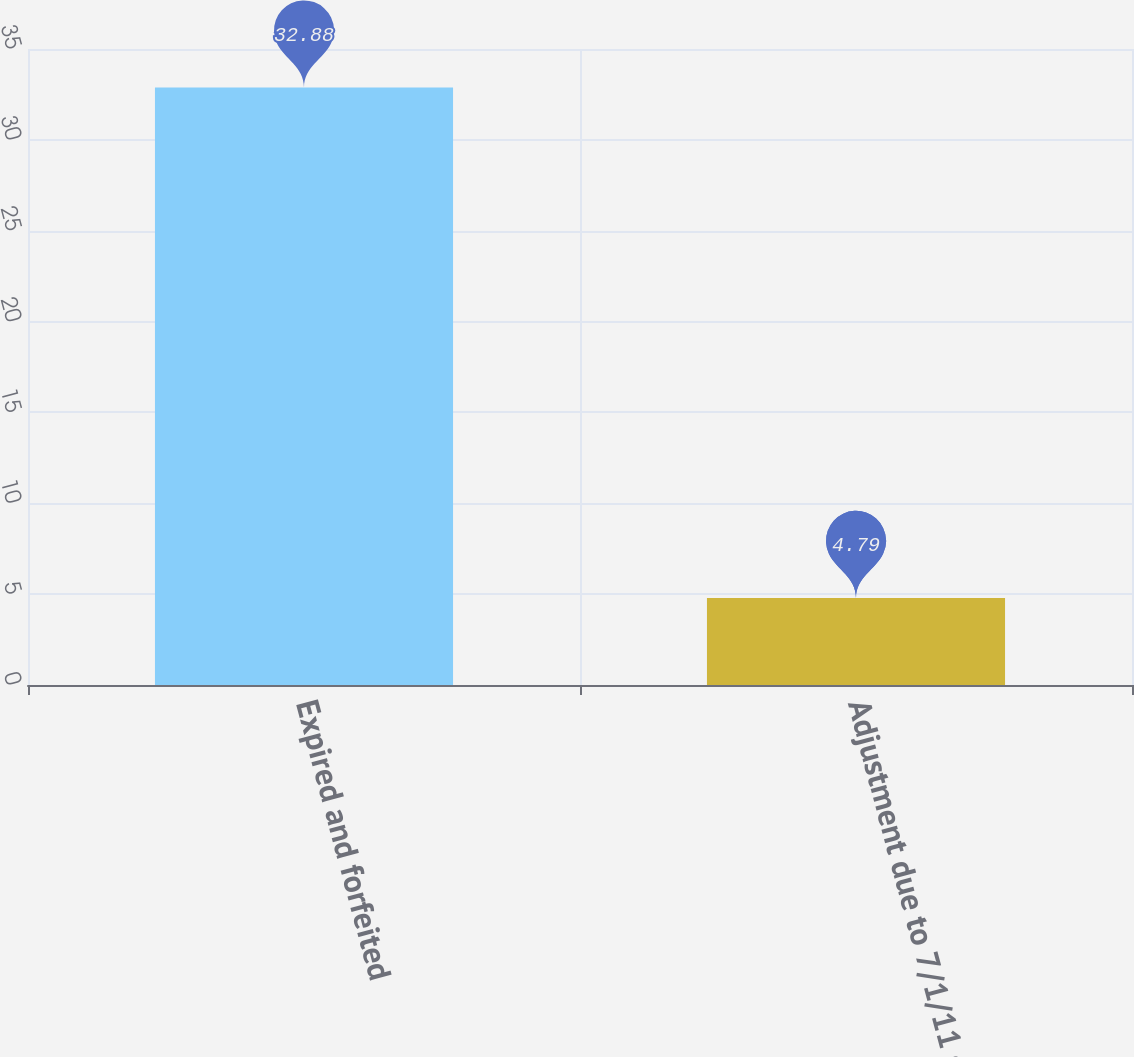Convert chart. <chart><loc_0><loc_0><loc_500><loc_500><bar_chart><fcel>Expired and forfeited<fcel>Adjustment due to 7/1/11 stock<nl><fcel>32.88<fcel>4.79<nl></chart> 